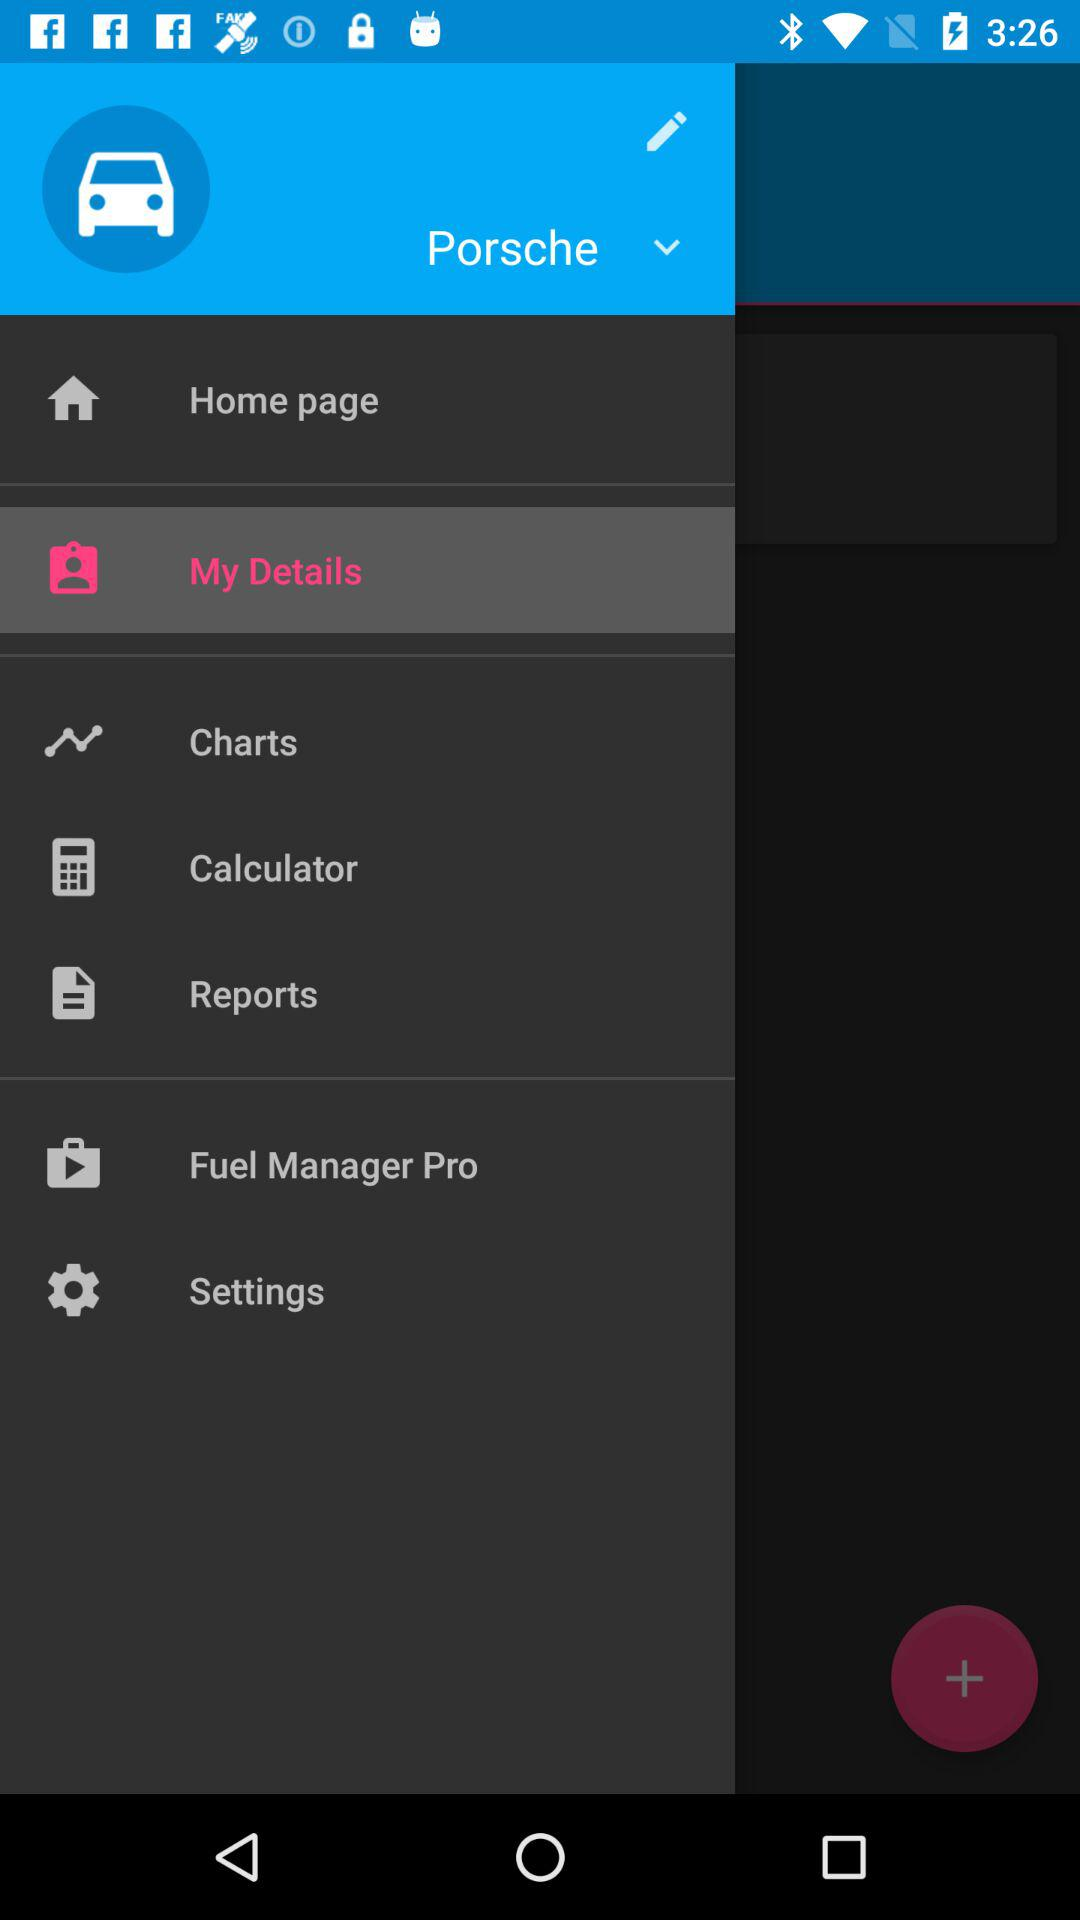What is the name of vehicle? The name of the vehicle is "Porsche". 